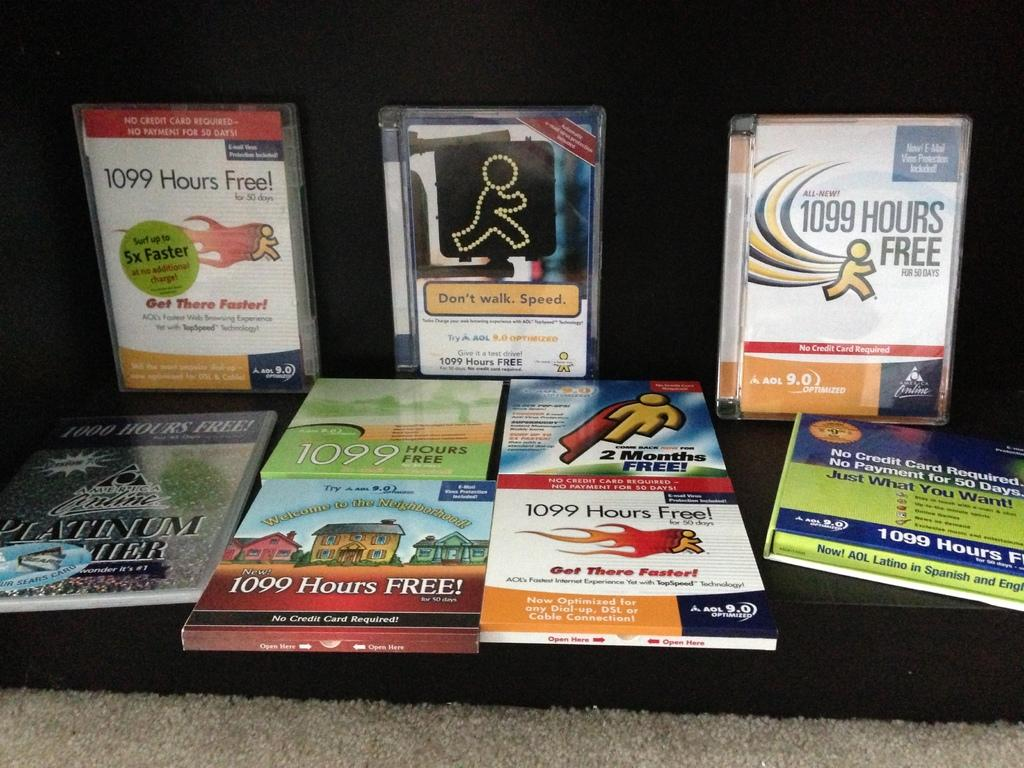<image>
Present a compact description of the photo's key features. Books on Technology usage like AOL and having up to 1099 free hours. 